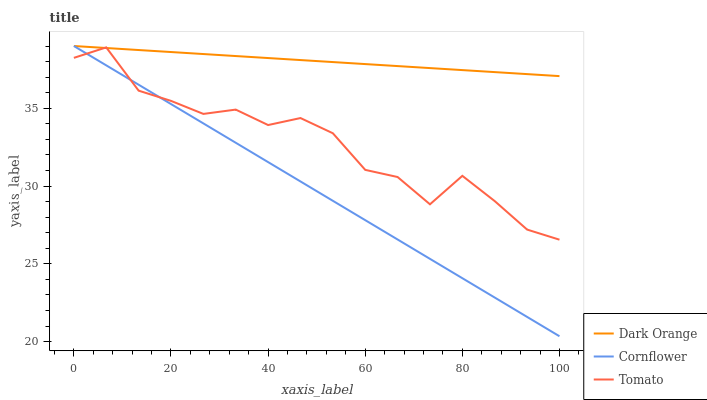Does Cornflower have the minimum area under the curve?
Answer yes or no. Yes. Does Dark Orange have the maximum area under the curve?
Answer yes or no. Yes. Does Dark Orange have the minimum area under the curve?
Answer yes or no. No. Does Cornflower have the maximum area under the curve?
Answer yes or no. No. Is Cornflower the smoothest?
Answer yes or no. Yes. Is Tomato the roughest?
Answer yes or no. Yes. Is Dark Orange the smoothest?
Answer yes or no. No. Is Dark Orange the roughest?
Answer yes or no. No. Does Dark Orange have the lowest value?
Answer yes or no. No. Does Cornflower have the highest value?
Answer yes or no. Yes. Does Cornflower intersect Dark Orange?
Answer yes or no. Yes. Is Cornflower less than Dark Orange?
Answer yes or no. No. Is Cornflower greater than Dark Orange?
Answer yes or no. No. 